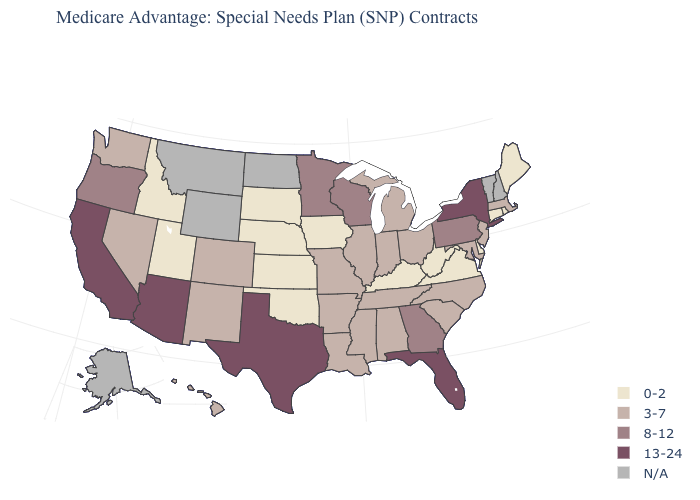What is the value of California?
Concise answer only. 13-24. How many symbols are there in the legend?
Answer briefly. 5. Which states have the lowest value in the West?
Short answer required. Idaho, Utah. Name the states that have a value in the range N/A?
Be succinct. Alaska, Montana, North Dakota, New Hampshire, Vermont, Wyoming. How many symbols are there in the legend?
Write a very short answer. 5. Which states hav the highest value in the MidWest?
Concise answer only. Minnesota, Wisconsin. Name the states that have a value in the range 13-24?
Give a very brief answer. Arizona, California, Florida, New York, Texas. Name the states that have a value in the range 13-24?
Write a very short answer. Arizona, California, Florida, New York, Texas. Is the legend a continuous bar?
Quick response, please. No. Which states hav the highest value in the South?
Be succinct. Florida, Texas. Name the states that have a value in the range 13-24?
Answer briefly. Arizona, California, Florida, New York, Texas. Which states have the lowest value in the USA?
Write a very short answer. Connecticut, Delaware, Iowa, Idaho, Kansas, Kentucky, Maine, Nebraska, Oklahoma, Rhode Island, South Dakota, Utah, Virginia, West Virginia. Which states hav the highest value in the MidWest?
Give a very brief answer. Minnesota, Wisconsin. What is the lowest value in states that border Iowa?
Concise answer only. 0-2. What is the highest value in the West ?
Answer briefly. 13-24. 